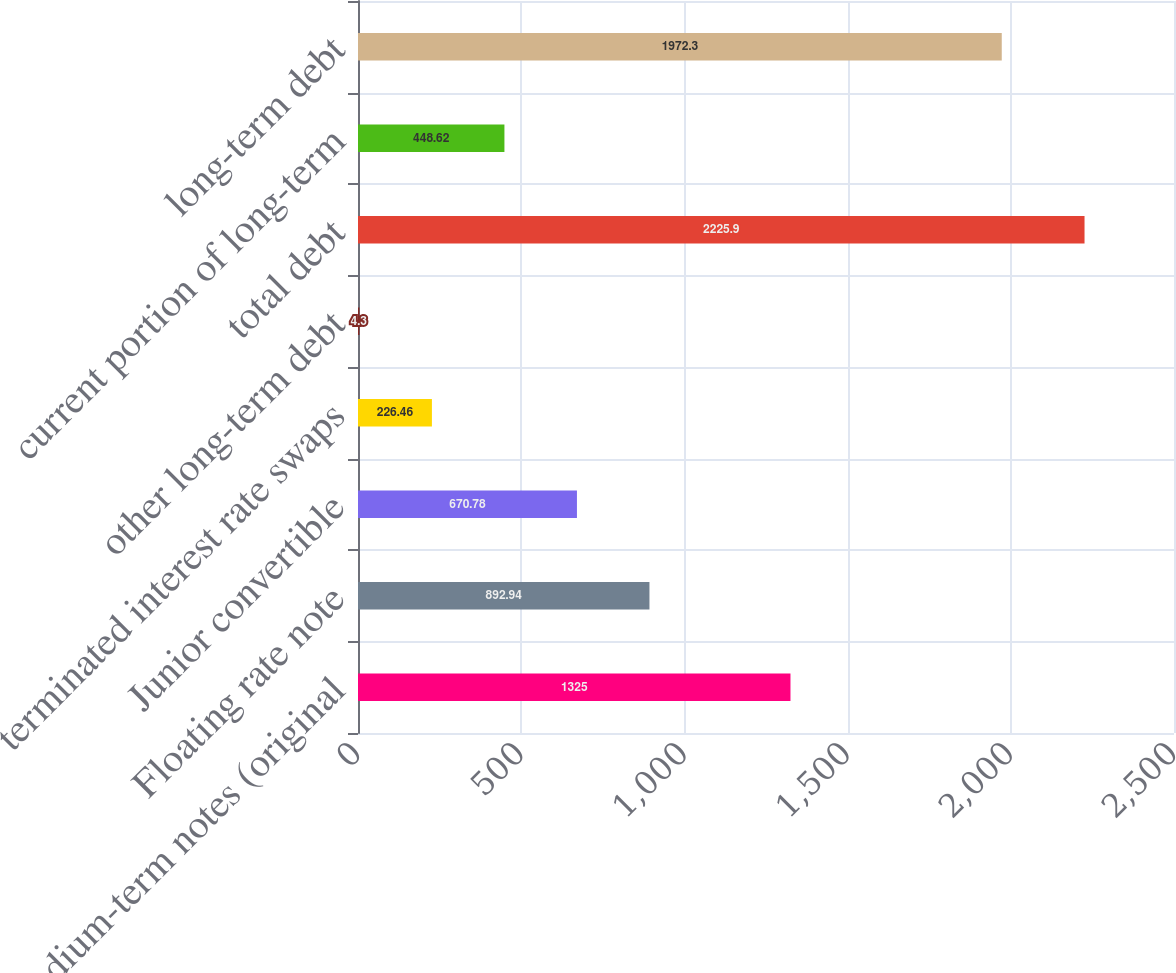<chart> <loc_0><loc_0><loc_500><loc_500><bar_chart><fcel>medium-term notes (original<fcel>Floating rate note<fcel>Junior convertible<fcel>terminated interest rate swaps<fcel>other long-term debt<fcel>total debt<fcel>current portion of long-term<fcel>long-term debt<nl><fcel>1325<fcel>892.94<fcel>670.78<fcel>226.46<fcel>4.3<fcel>2225.9<fcel>448.62<fcel>1972.3<nl></chart> 